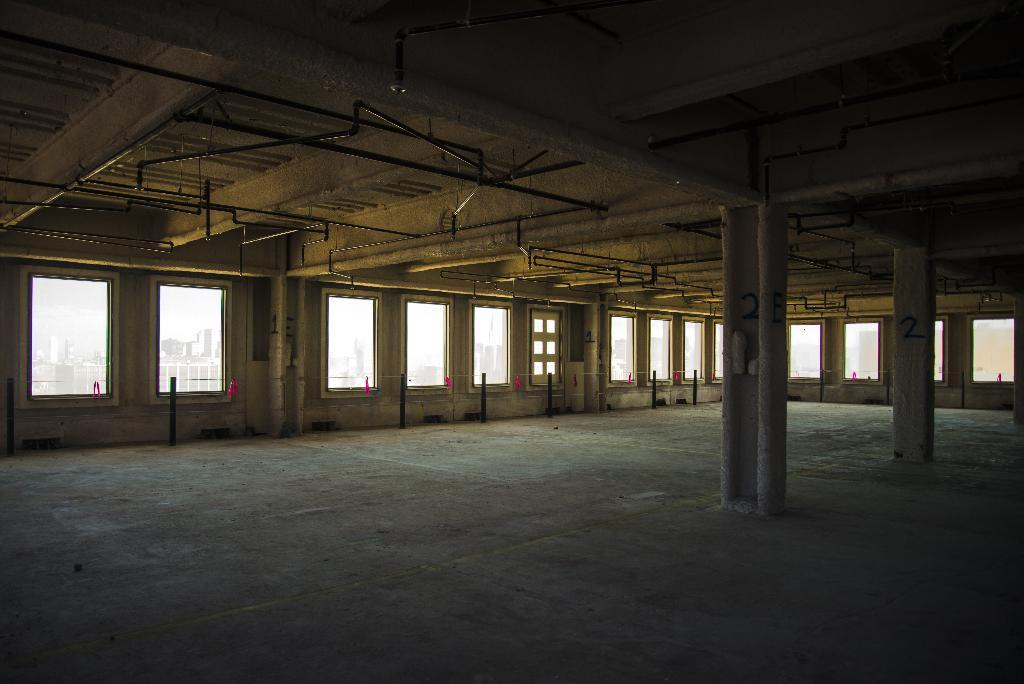What is the main feature of the image? The image contains an empty floor. Are there any structures on the floor? Yes, there are two pillars on the floor. What can be seen through the windows in the image? The presence of many windows suggests that there is a view of the outside, but the specific view is not mentioned in the facts. What type of cream is being applied to the girl's face in the image? There is no girl or cream present in the image. Is the girl driving a car in the image? There is no girl or car present in the image. 